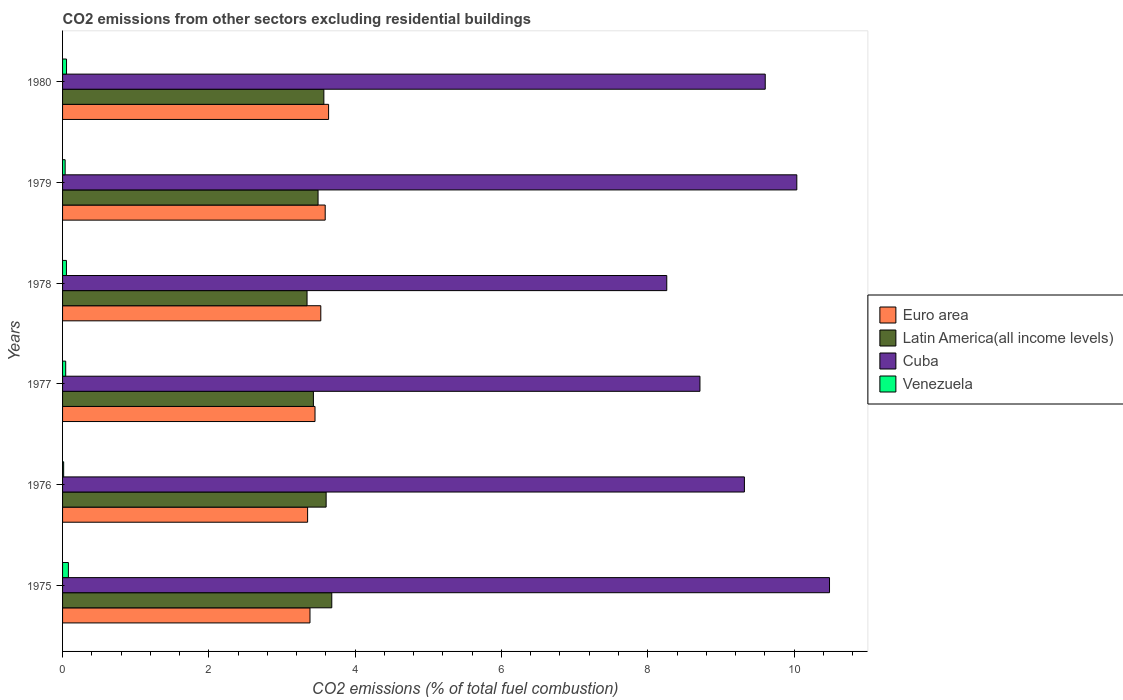How many different coloured bars are there?
Ensure brevity in your answer.  4. Are the number of bars per tick equal to the number of legend labels?
Your answer should be compact. Yes. How many bars are there on the 3rd tick from the top?
Keep it short and to the point. 4. How many bars are there on the 5th tick from the bottom?
Your answer should be very brief. 4. What is the label of the 6th group of bars from the top?
Ensure brevity in your answer.  1975. What is the total CO2 emitted in Euro area in 1977?
Ensure brevity in your answer.  3.45. Across all years, what is the maximum total CO2 emitted in Cuba?
Your answer should be very brief. 10.48. Across all years, what is the minimum total CO2 emitted in Latin America(all income levels)?
Your answer should be very brief. 3.34. In which year was the total CO2 emitted in Euro area maximum?
Give a very brief answer. 1980. In which year was the total CO2 emitted in Venezuela minimum?
Your answer should be compact. 1976. What is the total total CO2 emitted in Venezuela in the graph?
Make the answer very short. 0.28. What is the difference between the total CO2 emitted in Latin America(all income levels) in 1977 and that in 1978?
Ensure brevity in your answer.  0.09. What is the difference between the total CO2 emitted in Cuba in 1980 and the total CO2 emitted in Latin America(all income levels) in 1977?
Provide a succinct answer. 6.18. What is the average total CO2 emitted in Venezuela per year?
Your answer should be compact. 0.05. In the year 1975, what is the difference between the total CO2 emitted in Latin America(all income levels) and total CO2 emitted in Venezuela?
Give a very brief answer. 3.6. In how many years, is the total CO2 emitted in Cuba greater than 9.2 ?
Your response must be concise. 4. What is the ratio of the total CO2 emitted in Venezuela in 1975 to that in 1977?
Make the answer very short. 1.86. Is the total CO2 emitted in Euro area in 1976 less than that in 1978?
Offer a terse response. Yes. What is the difference between the highest and the second highest total CO2 emitted in Latin America(all income levels)?
Your answer should be compact. 0.08. What is the difference between the highest and the lowest total CO2 emitted in Latin America(all income levels)?
Provide a short and direct response. 0.34. In how many years, is the total CO2 emitted in Cuba greater than the average total CO2 emitted in Cuba taken over all years?
Your answer should be compact. 3. Is it the case that in every year, the sum of the total CO2 emitted in Euro area and total CO2 emitted in Venezuela is greater than the sum of total CO2 emitted in Latin America(all income levels) and total CO2 emitted in Cuba?
Your answer should be compact. Yes. What does the 3rd bar from the top in 1978 represents?
Ensure brevity in your answer.  Latin America(all income levels). What does the 3rd bar from the bottom in 1980 represents?
Offer a terse response. Cuba. Does the graph contain any zero values?
Your response must be concise. No. Does the graph contain grids?
Provide a succinct answer. No. Where does the legend appear in the graph?
Your response must be concise. Center right. How many legend labels are there?
Offer a terse response. 4. How are the legend labels stacked?
Your response must be concise. Vertical. What is the title of the graph?
Offer a very short reply. CO2 emissions from other sectors excluding residential buildings. Does "Guinea-Bissau" appear as one of the legend labels in the graph?
Your response must be concise. No. What is the label or title of the X-axis?
Keep it short and to the point. CO2 emissions (% of total fuel combustion). What is the label or title of the Y-axis?
Keep it short and to the point. Years. What is the CO2 emissions (% of total fuel combustion) of Euro area in 1975?
Offer a very short reply. 3.38. What is the CO2 emissions (% of total fuel combustion) in Latin America(all income levels) in 1975?
Offer a terse response. 3.68. What is the CO2 emissions (% of total fuel combustion) in Cuba in 1975?
Provide a succinct answer. 10.48. What is the CO2 emissions (% of total fuel combustion) in Venezuela in 1975?
Your answer should be compact. 0.08. What is the CO2 emissions (% of total fuel combustion) in Euro area in 1976?
Your response must be concise. 3.35. What is the CO2 emissions (% of total fuel combustion) in Latin America(all income levels) in 1976?
Your answer should be compact. 3.6. What is the CO2 emissions (% of total fuel combustion) of Cuba in 1976?
Ensure brevity in your answer.  9.32. What is the CO2 emissions (% of total fuel combustion) in Venezuela in 1976?
Your answer should be very brief. 0.01. What is the CO2 emissions (% of total fuel combustion) of Euro area in 1977?
Your response must be concise. 3.45. What is the CO2 emissions (% of total fuel combustion) in Latin America(all income levels) in 1977?
Offer a terse response. 3.43. What is the CO2 emissions (% of total fuel combustion) of Cuba in 1977?
Keep it short and to the point. 8.71. What is the CO2 emissions (% of total fuel combustion) of Venezuela in 1977?
Give a very brief answer. 0.04. What is the CO2 emissions (% of total fuel combustion) in Euro area in 1978?
Ensure brevity in your answer.  3.53. What is the CO2 emissions (% of total fuel combustion) of Latin America(all income levels) in 1978?
Offer a terse response. 3.34. What is the CO2 emissions (% of total fuel combustion) in Cuba in 1978?
Ensure brevity in your answer.  8.26. What is the CO2 emissions (% of total fuel combustion) in Venezuela in 1978?
Give a very brief answer. 0.05. What is the CO2 emissions (% of total fuel combustion) of Euro area in 1979?
Your answer should be very brief. 3.59. What is the CO2 emissions (% of total fuel combustion) of Latin America(all income levels) in 1979?
Your answer should be compact. 3.49. What is the CO2 emissions (% of total fuel combustion) in Cuba in 1979?
Make the answer very short. 10.04. What is the CO2 emissions (% of total fuel combustion) of Venezuela in 1979?
Ensure brevity in your answer.  0.04. What is the CO2 emissions (% of total fuel combustion) of Euro area in 1980?
Your response must be concise. 3.64. What is the CO2 emissions (% of total fuel combustion) in Latin America(all income levels) in 1980?
Provide a succinct answer. 3.57. What is the CO2 emissions (% of total fuel combustion) of Cuba in 1980?
Provide a succinct answer. 9.61. What is the CO2 emissions (% of total fuel combustion) in Venezuela in 1980?
Provide a short and direct response. 0.05. Across all years, what is the maximum CO2 emissions (% of total fuel combustion) of Euro area?
Your answer should be very brief. 3.64. Across all years, what is the maximum CO2 emissions (% of total fuel combustion) of Latin America(all income levels)?
Your answer should be compact. 3.68. Across all years, what is the maximum CO2 emissions (% of total fuel combustion) of Cuba?
Offer a very short reply. 10.48. Across all years, what is the maximum CO2 emissions (% of total fuel combustion) in Venezuela?
Offer a very short reply. 0.08. Across all years, what is the minimum CO2 emissions (% of total fuel combustion) of Euro area?
Your answer should be very brief. 3.35. Across all years, what is the minimum CO2 emissions (% of total fuel combustion) in Latin America(all income levels)?
Make the answer very short. 3.34. Across all years, what is the minimum CO2 emissions (% of total fuel combustion) in Cuba?
Offer a very short reply. 8.26. Across all years, what is the minimum CO2 emissions (% of total fuel combustion) of Venezuela?
Provide a succinct answer. 0.01. What is the total CO2 emissions (% of total fuel combustion) of Euro area in the graph?
Your answer should be compact. 20.94. What is the total CO2 emissions (% of total fuel combustion) of Latin America(all income levels) in the graph?
Your response must be concise. 21.12. What is the total CO2 emissions (% of total fuel combustion) of Cuba in the graph?
Your answer should be very brief. 56.42. What is the total CO2 emissions (% of total fuel combustion) of Venezuela in the graph?
Provide a short and direct response. 0.28. What is the difference between the CO2 emissions (% of total fuel combustion) in Euro area in 1975 and that in 1976?
Your answer should be compact. 0.03. What is the difference between the CO2 emissions (% of total fuel combustion) in Latin America(all income levels) in 1975 and that in 1976?
Your response must be concise. 0.08. What is the difference between the CO2 emissions (% of total fuel combustion) of Cuba in 1975 and that in 1976?
Provide a succinct answer. 1.16. What is the difference between the CO2 emissions (% of total fuel combustion) in Venezuela in 1975 and that in 1976?
Keep it short and to the point. 0.06. What is the difference between the CO2 emissions (% of total fuel combustion) of Euro area in 1975 and that in 1977?
Your response must be concise. -0.07. What is the difference between the CO2 emissions (% of total fuel combustion) in Latin America(all income levels) in 1975 and that in 1977?
Provide a succinct answer. 0.25. What is the difference between the CO2 emissions (% of total fuel combustion) of Cuba in 1975 and that in 1977?
Offer a terse response. 1.77. What is the difference between the CO2 emissions (% of total fuel combustion) in Venezuela in 1975 and that in 1977?
Provide a short and direct response. 0.04. What is the difference between the CO2 emissions (% of total fuel combustion) in Euro area in 1975 and that in 1978?
Your answer should be compact. -0.15. What is the difference between the CO2 emissions (% of total fuel combustion) in Latin America(all income levels) in 1975 and that in 1978?
Provide a succinct answer. 0.34. What is the difference between the CO2 emissions (% of total fuel combustion) of Cuba in 1975 and that in 1978?
Offer a terse response. 2.22. What is the difference between the CO2 emissions (% of total fuel combustion) in Venezuela in 1975 and that in 1978?
Your answer should be very brief. 0.03. What is the difference between the CO2 emissions (% of total fuel combustion) of Euro area in 1975 and that in 1979?
Ensure brevity in your answer.  -0.21. What is the difference between the CO2 emissions (% of total fuel combustion) in Latin America(all income levels) in 1975 and that in 1979?
Provide a succinct answer. 0.19. What is the difference between the CO2 emissions (% of total fuel combustion) in Cuba in 1975 and that in 1979?
Ensure brevity in your answer.  0.45. What is the difference between the CO2 emissions (% of total fuel combustion) of Venezuela in 1975 and that in 1979?
Provide a succinct answer. 0.04. What is the difference between the CO2 emissions (% of total fuel combustion) in Euro area in 1975 and that in 1980?
Offer a terse response. -0.25. What is the difference between the CO2 emissions (% of total fuel combustion) in Latin America(all income levels) in 1975 and that in 1980?
Ensure brevity in your answer.  0.11. What is the difference between the CO2 emissions (% of total fuel combustion) in Cuba in 1975 and that in 1980?
Offer a very short reply. 0.88. What is the difference between the CO2 emissions (% of total fuel combustion) in Venezuela in 1975 and that in 1980?
Provide a short and direct response. 0.03. What is the difference between the CO2 emissions (% of total fuel combustion) in Euro area in 1976 and that in 1977?
Your answer should be compact. -0.1. What is the difference between the CO2 emissions (% of total fuel combustion) of Latin America(all income levels) in 1976 and that in 1977?
Give a very brief answer. 0.17. What is the difference between the CO2 emissions (% of total fuel combustion) in Cuba in 1976 and that in 1977?
Your answer should be very brief. 0.61. What is the difference between the CO2 emissions (% of total fuel combustion) in Venezuela in 1976 and that in 1977?
Your answer should be compact. -0.03. What is the difference between the CO2 emissions (% of total fuel combustion) of Euro area in 1976 and that in 1978?
Provide a succinct answer. -0.18. What is the difference between the CO2 emissions (% of total fuel combustion) of Latin America(all income levels) in 1976 and that in 1978?
Offer a terse response. 0.26. What is the difference between the CO2 emissions (% of total fuel combustion) of Cuba in 1976 and that in 1978?
Offer a terse response. 1.06. What is the difference between the CO2 emissions (% of total fuel combustion) in Venezuela in 1976 and that in 1978?
Give a very brief answer. -0.04. What is the difference between the CO2 emissions (% of total fuel combustion) of Euro area in 1976 and that in 1979?
Give a very brief answer. -0.24. What is the difference between the CO2 emissions (% of total fuel combustion) of Latin America(all income levels) in 1976 and that in 1979?
Make the answer very short. 0.11. What is the difference between the CO2 emissions (% of total fuel combustion) of Cuba in 1976 and that in 1979?
Offer a terse response. -0.72. What is the difference between the CO2 emissions (% of total fuel combustion) in Venezuela in 1976 and that in 1979?
Provide a succinct answer. -0.02. What is the difference between the CO2 emissions (% of total fuel combustion) of Euro area in 1976 and that in 1980?
Offer a very short reply. -0.29. What is the difference between the CO2 emissions (% of total fuel combustion) of Latin America(all income levels) in 1976 and that in 1980?
Keep it short and to the point. 0.03. What is the difference between the CO2 emissions (% of total fuel combustion) in Cuba in 1976 and that in 1980?
Provide a succinct answer. -0.28. What is the difference between the CO2 emissions (% of total fuel combustion) of Venezuela in 1976 and that in 1980?
Your answer should be very brief. -0.04. What is the difference between the CO2 emissions (% of total fuel combustion) in Euro area in 1977 and that in 1978?
Ensure brevity in your answer.  -0.08. What is the difference between the CO2 emissions (% of total fuel combustion) in Latin America(all income levels) in 1977 and that in 1978?
Provide a succinct answer. 0.09. What is the difference between the CO2 emissions (% of total fuel combustion) in Cuba in 1977 and that in 1978?
Provide a short and direct response. 0.45. What is the difference between the CO2 emissions (% of total fuel combustion) in Venezuela in 1977 and that in 1978?
Your response must be concise. -0.01. What is the difference between the CO2 emissions (% of total fuel combustion) of Euro area in 1977 and that in 1979?
Make the answer very short. -0.14. What is the difference between the CO2 emissions (% of total fuel combustion) of Latin America(all income levels) in 1977 and that in 1979?
Keep it short and to the point. -0.06. What is the difference between the CO2 emissions (% of total fuel combustion) in Cuba in 1977 and that in 1979?
Your answer should be compact. -1.32. What is the difference between the CO2 emissions (% of total fuel combustion) in Venezuela in 1977 and that in 1979?
Make the answer very short. 0.01. What is the difference between the CO2 emissions (% of total fuel combustion) in Euro area in 1977 and that in 1980?
Ensure brevity in your answer.  -0.19. What is the difference between the CO2 emissions (% of total fuel combustion) in Latin America(all income levels) in 1977 and that in 1980?
Provide a succinct answer. -0.14. What is the difference between the CO2 emissions (% of total fuel combustion) in Cuba in 1977 and that in 1980?
Your response must be concise. -0.89. What is the difference between the CO2 emissions (% of total fuel combustion) in Venezuela in 1977 and that in 1980?
Your answer should be very brief. -0.01. What is the difference between the CO2 emissions (% of total fuel combustion) of Euro area in 1978 and that in 1979?
Offer a terse response. -0.06. What is the difference between the CO2 emissions (% of total fuel combustion) of Latin America(all income levels) in 1978 and that in 1979?
Your answer should be very brief. -0.15. What is the difference between the CO2 emissions (% of total fuel combustion) in Cuba in 1978 and that in 1979?
Offer a terse response. -1.78. What is the difference between the CO2 emissions (% of total fuel combustion) in Venezuela in 1978 and that in 1979?
Your response must be concise. 0.02. What is the difference between the CO2 emissions (% of total fuel combustion) of Euro area in 1978 and that in 1980?
Your answer should be very brief. -0.11. What is the difference between the CO2 emissions (% of total fuel combustion) in Latin America(all income levels) in 1978 and that in 1980?
Ensure brevity in your answer.  -0.23. What is the difference between the CO2 emissions (% of total fuel combustion) of Cuba in 1978 and that in 1980?
Ensure brevity in your answer.  -1.35. What is the difference between the CO2 emissions (% of total fuel combustion) of Venezuela in 1978 and that in 1980?
Provide a succinct answer. -0. What is the difference between the CO2 emissions (% of total fuel combustion) in Euro area in 1979 and that in 1980?
Your answer should be compact. -0.05. What is the difference between the CO2 emissions (% of total fuel combustion) of Latin America(all income levels) in 1979 and that in 1980?
Provide a short and direct response. -0.08. What is the difference between the CO2 emissions (% of total fuel combustion) of Cuba in 1979 and that in 1980?
Ensure brevity in your answer.  0.43. What is the difference between the CO2 emissions (% of total fuel combustion) in Venezuela in 1979 and that in 1980?
Your answer should be compact. -0.02. What is the difference between the CO2 emissions (% of total fuel combustion) of Euro area in 1975 and the CO2 emissions (% of total fuel combustion) of Latin America(all income levels) in 1976?
Your answer should be compact. -0.22. What is the difference between the CO2 emissions (% of total fuel combustion) of Euro area in 1975 and the CO2 emissions (% of total fuel combustion) of Cuba in 1976?
Make the answer very short. -5.94. What is the difference between the CO2 emissions (% of total fuel combustion) of Euro area in 1975 and the CO2 emissions (% of total fuel combustion) of Venezuela in 1976?
Give a very brief answer. 3.37. What is the difference between the CO2 emissions (% of total fuel combustion) of Latin America(all income levels) in 1975 and the CO2 emissions (% of total fuel combustion) of Cuba in 1976?
Offer a terse response. -5.64. What is the difference between the CO2 emissions (% of total fuel combustion) in Latin America(all income levels) in 1975 and the CO2 emissions (% of total fuel combustion) in Venezuela in 1976?
Offer a very short reply. 3.67. What is the difference between the CO2 emissions (% of total fuel combustion) in Cuba in 1975 and the CO2 emissions (% of total fuel combustion) in Venezuela in 1976?
Give a very brief answer. 10.47. What is the difference between the CO2 emissions (% of total fuel combustion) of Euro area in 1975 and the CO2 emissions (% of total fuel combustion) of Latin America(all income levels) in 1977?
Your answer should be very brief. -0.05. What is the difference between the CO2 emissions (% of total fuel combustion) in Euro area in 1975 and the CO2 emissions (% of total fuel combustion) in Cuba in 1977?
Ensure brevity in your answer.  -5.33. What is the difference between the CO2 emissions (% of total fuel combustion) of Euro area in 1975 and the CO2 emissions (% of total fuel combustion) of Venezuela in 1977?
Provide a short and direct response. 3.34. What is the difference between the CO2 emissions (% of total fuel combustion) of Latin America(all income levels) in 1975 and the CO2 emissions (% of total fuel combustion) of Cuba in 1977?
Ensure brevity in your answer.  -5.03. What is the difference between the CO2 emissions (% of total fuel combustion) of Latin America(all income levels) in 1975 and the CO2 emissions (% of total fuel combustion) of Venezuela in 1977?
Your response must be concise. 3.64. What is the difference between the CO2 emissions (% of total fuel combustion) in Cuba in 1975 and the CO2 emissions (% of total fuel combustion) in Venezuela in 1977?
Make the answer very short. 10.44. What is the difference between the CO2 emissions (% of total fuel combustion) of Euro area in 1975 and the CO2 emissions (% of total fuel combustion) of Latin America(all income levels) in 1978?
Give a very brief answer. 0.04. What is the difference between the CO2 emissions (% of total fuel combustion) of Euro area in 1975 and the CO2 emissions (% of total fuel combustion) of Cuba in 1978?
Your answer should be very brief. -4.88. What is the difference between the CO2 emissions (% of total fuel combustion) in Euro area in 1975 and the CO2 emissions (% of total fuel combustion) in Venezuela in 1978?
Offer a very short reply. 3.33. What is the difference between the CO2 emissions (% of total fuel combustion) in Latin America(all income levels) in 1975 and the CO2 emissions (% of total fuel combustion) in Cuba in 1978?
Offer a very short reply. -4.58. What is the difference between the CO2 emissions (% of total fuel combustion) in Latin America(all income levels) in 1975 and the CO2 emissions (% of total fuel combustion) in Venezuela in 1978?
Provide a short and direct response. 3.63. What is the difference between the CO2 emissions (% of total fuel combustion) in Cuba in 1975 and the CO2 emissions (% of total fuel combustion) in Venezuela in 1978?
Keep it short and to the point. 10.43. What is the difference between the CO2 emissions (% of total fuel combustion) of Euro area in 1975 and the CO2 emissions (% of total fuel combustion) of Latin America(all income levels) in 1979?
Offer a very short reply. -0.11. What is the difference between the CO2 emissions (% of total fuel combustion) of Euro area in 1975 and the CO2 emissions (% of total fuel combustion) of Cuba in 1979?
Keep it short and to the point. -6.66. What is the difference between the CO2 emissions (% of total fuel combustion) of Euro area in 1975 and the CO2 emissions (% of total fuel combustion) of Venezuela in 1979?
Offer a terse response. 3.35. What is the difference between the CO2 emissions (% of total fuel combustion) in Latin America(all income levels) in 1975 and the CO2 emissions (% of total fuel combustion) in Cuba in 1979?
Ensure brevity in your answer.  -6.36. What is the difference between the CO2 emissions (% of total fuel combustion) of Latin America(all income levels) in 1975 and the CO2 emissions (% of total fuel combustion) of Venezuela in 1979?
Provide a succinct answer. 3.65. What is the difference between the CO2 emissions (% of total fuel combustion) in Cuba in 1975 and the CO2 emissions (% of total fuel combustion) in Venezuela in 1979?
Make the answer very short. 10.45. What is the difference between the CO2 emissions (% of total fuel combustion) of Euro area in 1975 and the CO2 emissions (% of total fuel combustion) of Latin America(all income levels) in 1980?
Keep it short and to the point. -0.19. What is the difference between the CO2 emissions (% of total fuel combustion) of Euro area in 1975 and the CO2 emissions (% of total fuel combustion) of Cuba in 1980?
Your answer should be compact. -6.22. What is the difference between the CO2 emissions (% of total fuel combustion) in Euro area in 1975 and the CO2 emissions (% of total fuel combustion) in Venezuela in 1980?
Make the answer very short. 3.33. What is the difference between the CO2 emissions (% of total fuel combustion) in Latin America(all income levels) in 1975 and the CO2 emissions (% of total fuel combustion) in Cuba in 1980?
Give a very brief answer. -5.93. What is the difference between the CO2 emissions (% of total fuel combustion) of Latin America(all income levels) in 1975 and the CO2 emissions (% of total fuel combustion) of Venezuela in 1980?
Provide a short and direct response. 3.63. What is the difference between the CO2 emissions (% of total fuel combustion) in Cuba in 1975 and the CO2 emissions (% of total fuel combustion) in Venezuela in 1980?
Ensure brevity in your answer.  10.43. What is the difference between the CO2 emissions (% of total fuel combustion) in Euro area in 1976 and the CO2 emissions (% of total fuel combustion) in Latin America(all income levels) in 1977?
Your answer should be very brief. -0.08. What is the difference between the CO2 emissions (% of total fuel combustion) of Euro area in 1976 and the CO2 emissions (% of total fuel combustion) of Cuba in 1977?
Ensure brevity in your answer.  -5.36. What is the difference between the CO2 emissions (% of total fuel combustion) in Euro area in 1976 and the CO2 emissions (% of total fuel combustion) in Venezuela in 1977?
Provide a short and direct response. 3.31. What is the difference between the CO2 emissions (% of total fuel combustion) of Latin America(all income levels) in 1976 and the CO2 emissions (% of total fuel combustion) of Cuba in 1977?
Keep it short and to the point. -5.11. What is the difference between the CO2 emissions (% of total fuel combustion) in Latin America(all income levels) in 1976 and the CO2 emissions (% of total fuel combustion) in Venezuela in 1977?
Your answer should be compact. 3.56. What is the difference between the CO2 emissions (% of total fuel combustion) in Cuba in 1976 and the CO2 emissions (% of total fuel combustion) in Venezuela in 1977?
Keep it short and to the point. 9.28. What is the difference between the CO2 emissions (% of total fuel combustion) in Euro area in 1976 and the CO2 emissions (% of total fuel combustion) in Latin America(all income levels) in 1978?
Your answer should be compact. 0.01. What is the difference between the CO2 emissions (% of total fuel combustion) of Euro area in 1976 and the CO2 emissions (% of total fuel combustion) of Cuba in 1978?
Offer a terse response. -4.91. What is the difference between the CO2 emissions (% of total fuel combustion) of Euro area in 1976 and the CO2 emissions (% of total fuel combustion) of Venezuela in 1978?
Make the answer very short. 3.3. What is the difference between the CO2 emissions (% of total fuel combustion) of Latin America(all income levels) in 1976 and the CO2 emissions (% of total fuel combustion) of Cuba in 1978?
Provide a short and direct response. -4.66. What is the difference between the CO2 emissions (% of total fuel combustion) in Latin America(all income levels) in 1976 and the CO2 emissions (% of total fuel combustion) in Venezuela in 1978?
Keep it short and to the point. 3.55. What is the difference between the CO2 emissions (% of total fuel combustion) of Cuba in 1976 and the CO2 emissions (% of total fuel combustion) of Venezuela in 1978?
Keep it short and to the point. 9.27. What is the difference between the CO2 emissions (% of total fuel combustion) in Euro area in 1976 and the CO2 emissions (% of total fuel combustion) in Latin America(all income levels) in 1979?
Provide a succinct answer. -0.14. What is the difference between the CO2 emissions (% of total fuel combustion) of Euro area in 1976 and the CO2 emissions (% of total fuel combustion) of Cuba in 1979?
Provide a short and direct response. -6.69. What is the difference between the CO2 emissions (% of total fuel combustion) of Euro area in 1976 and the CO2 emissions (% of total fuel combustion) of Venezuela in 1979?
Offer a terse response. 3.31. What is the difference between the CO2 emissions (% of total fuel combustion) of Latin America(all income levels) in 1976 and the CO2 emissions (% of total fuel combustion) of Cuba in 1979?
Ensure brevity in your answer.  -6.43. What is the difference between the CO2 emissions (% of total fuel combustion) in Latin America(all income levels) in 1976 and the CO2 emissions (% of total fuel combustion) in Venezuela in 1979?
Offer a very short reply. 3.57. What is the difference between the CO2 emissions (% of total fuel combustion) of Cuba in 1976 and the CO2 emissions (% of total fuel combustion) of Venezuela in 1979?
Give a very brief answer. 9.29. What is the difference between the CO2 emissions (% of total fuel combustion) of Euro area in 1976 and the CO2 emissions (% of total fuel combustion) of Latin America(all income levels) in 1980?
Provide a short and direct response. -0.22. What is the difference between the CO2 emissions (% of total fuel combustion) of Euro area in 1976 and the CO2 emissions (% of total fuel combustion) of Cuba in 1980?
Provide a short and direct response. -6.26. What is the difference between the CO2 emissions (% of total fuel combustion) in Euro area in 1976 and the CO2 emissions (% of total fuel combustion) in Venezuela in 1980?
Provide a succinct answer. 3.3. What is the difference between the CO2 emissions (% of total fuel combustion) of Latin America(all income levels) in 1976 and the CO2 emissions (% of total fuel combustion) of Cuba in 1980?
Keep it short and to the point. -6. What is the difference between the CO2 emissions (% of total fuel combustion) of Latin America(all income levels) in 1976 and the CO2 emissions (% of total fuel combustion) of Venezuela in 1980?
Offer a terse response. 3.55. What is the difference between the CO2 emissions (% of total fuel combustion) of Cuba in 1976 and the CO2 emissions (% of total fuel combustion) of Venezuela in 1980?
Your answer should be very brief. 9.27. What is the difference between the CO2 emissions (% of total fuel combustion) in Euro area in 1977 and the CO2 emissions (% of total fuel combustion) in Latin America(all income levels) in 1978?
Provide a succinct answer. 0.11. What is the difference between the CO2 emissions (% of total fuel combustion) of Euro area in 1977 and the CO2 emissions (% of total fuel combustion) of Cuba in 1978?
Offer a terse response. -4.81. What is the difference between the CO2 emissions (% of total fuel combustion) of Euro area in 1977 and the CO2 emissions (% of total fuel combustion) of Venezuela in 1978?
Your answer should be compact. 3.4. What is the difference between the CO2 emissions (% of total fuel combustion) in Latin America(all income levels) in 1977 and the CO2 emissions (% of total fuel combustion) in Cuba in 1978?
Make the answer very short. -4.83. What is the difference between the CO2 emissions (% of total fuel combustion) in Latin America(all income levels) in 1977 and the CO2 emissions (% of total fuel combustion) in Venezuela in 1978?
Offer a terse response. 3.38. What is the difference between the CO2 emissions (% of total fuel combustion) in Cuba in 1977 and the CO2 emissions (% of total fuel combustion) in Venezuela in 1978?
Keep it short and to the point. 8.66. What is the difference between the CO2 emissions (% of total fuel combustion) of Euro area in 1977 and the CO2 emissions (% of total fuel combustion) of Latin America(all income levels) in 1979?
Make the answer very short. -0.04. What is the difference between the CO2 emissions (% of total fuel combustion) in Euro area in 1977 and the CO2 emissions (% of total fuel combustion) in Cuba in 1979?
Your response must be concise. -6.59. What is the difference between the CO2 emissions (% of total fuel combustion) of Euro area in 1977 and the CO2 emissions (% of total fuel combustion) of Venezuela in 1979?
Provide a succinct answer. 3.42. What is the difference between the CO2 emissions (% of total fuel combustion) in Latin America(all income levels) in 1977 and the CO2 emissions (% of total fuel combustion) in Cuba in 1979?
Your response must be concise. -6.61. What is the difference between the CO2 emissions (% of total fuel combustion) in Latin America(all income levels) in 1977 and the CO2 emissions (% of total fuel combustion) in Venezuela in 1979?
Your answer should be compact. 3.39. What is the difference between the CO2 emissions (% of total fuel combustion) in Cuba in 1977 and the CO2 emissions (% of total fuel combustion) in Venezuela in 1979?
Your answer should be very brief. 8.68. What is the difference between the CO2 emissions (% of total fuel combustion) of Euro area in 1977 and the CO2 emissions (% of total fuel combustion) of Latin America(all income levels) in 1980?
Ensure brevity in your answer.  -0.12. What is the difference between the CO2 emissions (% of total fuel combustion) in Euro area in 1977 and the CO2 emissions (% of total fuel combustion) in Cuba in 1980?
Your answer should be very brief. -6.15. What is the difference between the CO2 emissions (% of total fuel combustion) of Euro area in 1977 and the CO2 emissions (% of total fuel combustion) of Venezuela in 1980?
Provide a succinct answer. 3.4. What is the difference between the CO2 emissions (% of total fuel combustion) in Latin America(all income levels) in 1977 and the CO2 emissions (% of total fuel combustion) in Cuba in 1980?
Provide a short and direct response. -6.18. What is the difference between the CO2 emissions (% of total fuel combustion) of Latin America(all income levels) in 1977 and the CO2 emissions (% of total fuel combustion) of Venezuela in 1980?
Make the answer very short. 3.37. What is the difference between the CO2 emissions (% of total fuel combustion) in Cuba in 1977 and the CO2 emissions (% of total fuel combustion) in Venezuela in 1980?
Offer a terse response. 8.66. What is the difference between the CO2 emissions (% of total fuel combustion) in Euro area in 1978 and the CO2 emissions (% of total fuel combustion) in Latin America(all income levels) in 1979?
Keep it short and to the point. 0.04. What is the difference between the CO2 emissions (% of total fuel combustion) of Euro area in 1978 and the CO2 emissions (% of total fuel combustion) of Cuba in 1979?
Offer a very short reply. -6.51. What is the difference between the CO2 emissions (% of total fuel combustion) in Euro area in 1978 and the CO2 emissions (% of total fuel combustion) in Venezuela in 1979?
Ensure brevity in your answer.  3.5. What is the difference between the CO2 emissions (% of total fuel combustion) of Latin America(all income levels) in 1978 and the CO2 emissions (% of total fuel combustion) of Cuba in 1979?
Ensure brevity in your answer.  -6.7. What is the difference between the CO2 emissions (% of total fuel combustion) of Latin America(all income levels) in 1978 and the CO2 emissions (% of total fuel combustion) of Venezuela in 1979?
Your answer should be compact. 3.31. What is the difference between the CO2 emissions (% of total fuel combustion) of Cuba in 1978 and the CO2 emissions (% of total fuel combustion) of Venezuela in 1979?
Make the answer very short. 8.22. What is the difference between the CO2 emissions (% of total fuel combustion) of Euro area in 1978 and the CO2 emissions (% of total fuel combustion) of Latin America(all income levels) in 1980?
Your response must be concise. -0.04. What is the difference between the CO2 emissions (% of total fuel combustion) of Euro area in 1978 and the CO2 emissions (% of total fuel combustion) of Cuba in 1980?
Offer a terse response. -6.08. What is the difference between the CO2 emissions (% of total fuel combustion) of Euro area in 1978 and the CO2 emissions (% of total fuel combustion) of Venezuela in 1980?
Keep it short and to the point. 3.48. What is the difference between the CO2 emissions (% of total fuel combustion) in Latin America(all income levels) in 1978 and the CO2 emissions (% of total fuel combustion) in Cuba in 1980?
Make the answer very short. -6.26. What is the difference between the CO2 emissions (% of total fuel combustion) in Latin America(all income levels) in 1978 and the CO2 emissions (% of total fuel combustion) in Venezuela in 1980?
Provide a succinct answer. 3.29. What is the difference between the CO2 emissions (% of total fuel combustion) in Cuba in 1978 and the CO2 emissions (% of total fuel combustion) in Venezuela in 1980?
Provide a short and direct response. 8.21. What is the difference between the CO2 emissions (% of total fuel combustion) in Euro area in 1979 and the CO2 emissions (% of total fuel combustion) in Latin America(all income levels) in 1980?
Make the answer very short. 0.02. What is the difference between the CO2 emissions (% of total fuel combustion) in Euro area in 1979 and the CO2 emissions (% of total fuel combustion) in Cuba in 1980?
Provide a succinct answer. -6.02. What is the difference between the CO2 emissions (% of total fuel combustion) of Euro area in 1979 and the CO2 emissions (% of total fuel combustion) of Venezuela in 1980?
Keep it short and to the point. 3.54. What is the difference between the CO2 emissions (% of total fuel combustion) in Latin America(all income levels) in 1979 and the CO2 emissions (% of total fuel combustion) in Cuba in 1980?
Provide a short and direct response. -6.11. What is the difference between the CO2 emissions (% of total fuel combustion) of Latin America(all income levels) in 1979 and the CO2 emissions (% of total fuel combustion) of Venezuela in 1980?
Keep it short and to the point. 3.44. What is the difference between the CO2 emissions (% of total fuel combustion) in Cuba in 1979 and the CO2 emissions (% of total fuel combustion) in Venezuela in 1980?
Offer a terse response. 9.98. What is the average CO2 emissions (% of total fuel combustion) of Euro area per year?
Provide a succinct answer. 3.49. What is the average CO2 emissions (% of total fuel combustion) of Latin America(all income levels) per year?
Your answer should be compact. 3.52. What is the average CO2 emissions (% of total fuel combustion) of Cuba per year?
Give a very brief answer. 9.4. What is the average CO2 emissions (% of total fuel combustion) in Venezuela per year?
Your answer should be very brief. 0.05. In the year 1975, what is the difference between the CO2 emissions (% of total fuel combustion) of Euro area and CO2 emissions (% of total fuel combustion) of Latin America(all income levels)?
Provide a short and direct response. -0.3. In the year 1975, what is the difference between the CO2 emissions (% of total fuel combustion) of Euro area and CO2 emissions (% of total fuel combustion) of Cuba?
Your answer should be compact. -7.1. In the year 1975, what is the difference between the CO2 emissions (% of total fuel combustion) of Euro area and CO2 emissions (% of total fuel combustion) of Venezuela?
Your answer should be compact. 3.3. In the year 1975, what is the difference between the CO2 emissions (% of total fuel combustion) in Latin America(all income levels) and CO2 emissions (% of total fuel combustion) in Cuba?
Offer a terse response. -6.8. In the year 1975, what is the difference between the CO2 emissions (% of total fuel combustion) of Latin America(all income levels) and CO2 emissions (% of total fuel combustion) of Venezuela?
Offer a very short reply. 3.6. In the year 1975, what is the difference between the CO2 emissions (% of total fuel combustion) of Cuba and CO2 emissions (% of total fuel combustion) of Venezuela?
Provide a short and direct response. 10.4. In the year 1976, what is the difference between the CO2 emissions (% of total fuel combustion) of Euro area and CO2 emissions (% of total fuel combustion) of Latin America(all income levels)?
Provide a short and direct response. -0.25. In the year 1976, what is the difference between the CO2 emissions (% of total fuel combustion) of Euro area and CO2 emissions (% of total fuel combustion) of Cuba?
Your answer should be compact. -5.97. In the year 1976, what is the difference between the CO2 emissions (% of total fuel combustion) in Euro area and CO2 emissions (% of total fuel combustion) in Venezuela?
Keep it short and to the point. 3.33. In the year 1976, what is the difference between the CO2 emissions (% of total fuel combustion) in Latin America(all income levels) and CO2 emissions (% of total fuel combustion) in Cuba?
Offer a terse response. -5.72. In the year 1976, what is the difference between the CO2 emissions (% of total fuel combustion) in Latin America(all income levels) and CO2 emissions (% of total fuel combustion) in Venezuela?
Keep it short and to the point. 3.59. In the year 1976, what is the difference between the CO2 emissions (% of total fuel combustion) of Cuba and CO2 emissions (% of total fuel combustion) of Venezuela?
Offer a very short reply. 9.31. In the year 1977, what is the difference between the CO2 emissions (% of total fuel combustion) of Euro area and CO2 emissions (% of total fuel combustion) of Latin America(all income levels)?
Provide a succinct answer. 0.02. In the year 1977, what is the difference between the CO2 emissions (% of total fuel combustion) in Euro area and CO2 emissions (% of total fuel combustion) in Cuba?
Offer a terse response. -5.26. In the year 1977, what is the difference between the CO2 emissions (% of total fuel combustion) in Euro area and CO2 emissions (% of total fuel combustion) in Venezuela?
Give a very brief answer. 3.41. In the year 1977, what is the difference between the CO2 emissions (% of total fuel combustion) in Latin America(all income levels) and CO2 emissions (% of total fuel combustion) in Cuba?
Offer a very short reply. -5.28. In the year 1977, what is the difference between the CO2 emissions (% of total fuel combustion) of Latin America(all income levels) and CO2 emissions (% of total fuel combustion) of Venezuela?
Your response must be concise. 3.39. In the year 1977, what is the difference between the CO2 emissions (% of total fuel combustion) of Cuba and CO2 emissions (% of total fuel combustion) of Venezuela?
Offer a terse response. 8.67. In the year 1978, what is the difference between the CO2 emissions (% of total fuel combustion) in Euro area and CO2 emissions (% of total fuel combustion) in Latin America(all income levels)?
Offer a very short reply. 0.19. In the year 1978, what is the difference between the CO2 emissions (% of total fuel combustion) of Euro area and CO2 emissions (% of total fuel combustion) of Cuba?
Keep it short and to the point. -4.73. In the year 1978, what is the difference between the CO2 emissions (% of total fuel combustion) in Euro area and CO2 emissions (% of total fuel combustion) in Venezuela?
Offer a very short reply. 3.48. In the year 1978, what is the difference between the CO2 emissions (% of total fuel combustion) of Latin America(all income levels) and CO2 emissions (% of total fuel combustion) of Cuba?
Your answer should be very brief. -4.92. In the year 1978, what is the difference between the CO2 emissions (% of total fuel combustion) in Latin America(all income levels) and CO2 emissions (% of total fuel combustion) in Venezuela?
Your response must be concise. 3.29. In the year 1978, what is the difference between the CO2 emissions (% of total fuel combustion) of Cuba and CO2 emissions (% of total fuel combustion) of Venezuela?
Your answer should be very brief. 8.21. In the year 1979, what is the difference between the CO2 emissions (% of total fuel combustion) of Euro area and CO2 emissions (% of total fuel combustion) of Latin America(all income levels)?
Your response must be concise. 0.1. In the year 1979, what is the difference between the CO2 emissions (% of total fuel combustion) of Euro area and CO2 emissions (% of total fuel combustion) of Cuba?
Your answer should be very brief. -6.45. In the year 1979, what is the difference between the CO2 emissions (% of total fuel combustion) of Euro area and CO2 emissions (% of total fuel combustion) of Venezuela?
Ensure brevity in your answer.  3.56. In the year 1979, what is the difference between the CO2 emissions (% of total fuel combustion) of Latin America(all income levels) and CO2 emissions (% of total fuel combustion) of Cuba?
Your answer should be compact. -6.54. In the year 1979, what is the difference between the CO2 emissions (% of total fuel combustion) in Latin America(all income levels) and CO2 emissions (% of total fuel combustion) in Venezuela?
Offer a terse response. 3.46. In the year 1979, what is the difference between the CO2 emissions (% of total fuel combustion) in Cuba and CO2 emissions (% of total fuel combustion) in Venezuela?
Provide a succinct answer. 10. In the year 1980, what is the difference between the CO2 emissions (% of total fuel combustion) in Euro area and CO2 emissions (% of total fuel combustion) in Latin America(all income levels)?
Make the answer very short. 0.06. In the year 1980, what is the difference between the CO2 emissions (% of total fuel combustion) in Euro area and CO2 emissions (% of total fuel combustion) in Cuba?
Provide a short and direct response. -5.97. In the year 1980, what is the difference between the CO2 emissions (% of total fuel combustion) in Euro area and CO2 emissions (% of total fuel combustion) in Venezuela?
Give a very brief answer. 3.58. In the year 1980, what is the difference between the CO2 emissions (% of total fuel combustion) of Latin America(all income levels) and CO2 emissions (% of total fuel combustion) of Cuba?
Offer a very short reply. -6.03. In the year 1980, what is the difference between the CO2 emissions (% of total fuel combustion) in Latin America(all income levels) and CO2 emissions (% of total fuel combustion) in Venezuela?
Keep it short and to the point. 3.52. In the year 1980, what is the difference between the CO2 emissions (% of total fuel combustion) of Cuba and CO2 emissions (% of total fuel combustion) of Venezuela?
Keep it short and to the point. 9.55. What is the ratio of the CO2 emissions (% of total fuel combustion) in Euro area in 1975 to that in 1976?
Make the answer very short. 1.01. What is the ratio of the CO2 emissions (% of total fuel combustion) in Latin America(all income levels) in 1975 to that in 1976?
Keep it short and to the point. 1.02. What is the ratio of the CO2 emissions (% of total fuel combustion) of Cuba in 1975 to that in 1976?
Your answer should be compact. 1.12. What is the ratio of the CO2 emissions (% of total fuel combustion) in Venezuela in 1975 to that in 1976?
Offer a terse response. 5.37. What is the ratio of the CO2 emissions (% of total fuel combustion) of Euro area in 1975 to that in 1977?
Offer a very short reply. 0.98. What is the ratio of the CO2 emissions (% of total fuel combustion) of Latin America(all income levels) in 1975 to that in 1977?
Make the answer very short. 1.07. What is the ratio of the CO2 emissions (% of total fuel combustion) of Cuba in 1975 to that in 1977?
Make the answer very short. 1.2. What is the ratio of the CO2 emissions (% of total fuel combustion) in Venezuela in 1975 to that in 1977?
Make the answer very short. 1.86. What is the ratio of the CO2 emissions (% of total fuel combustion) in Euro area in 1975 to that in 1978?
Your answer should be very brief. 0.96. What is the ratio of the CO2 emissions (% of total fuel combustion) of Latin America(all income levels) in 1975 to that in 1978?
Your answer should be compact. 1.1. What is the ratio of the CO2 emissions (% of total fuel combustion) of Cuba in 1975 to that in 1978?
Provide a short and direct response. 1.27. What is the ratio of the CO2 emissions (% of total fuel combustion) of Venezuela in 1975 to that in 1978?
Provide a succinct answer. 1.5. What is the ratio of the CO2 emissions (% of total fuel combustion) in Euro area in 1975 to that in 1979?
Provide a succinct answer. 0.94. What is the ratio of the CO2 emissions (% of total fuel combustion) of Latin America(all income levels) in 1975 to that in 1979?
Keep it short and to the point. 1.05. What is the ratio of the CO2 emissions (% of total fuel combustion) in Cuba in 1975 to that in 1979?
Offer a very short reply. 1.04. What is the ratio of the CO2 emissions (% of total fuel combustion) in Venezuela in 1975 to that in 1979?
Offer a very short reply. 2.26. What is the ratio of the CO2 emissions (% of total fuel combustion) of Euro area in 1975 to that in 1980?
Your answer should be very brief. 0.93. What is the ratio of the CO2 emissions (% of total fuel combustion) of Latin America(all income levels) in 1975 to that in 1980?
Provide a short and direct response. 1.03. What is the ratio of the CO2 emissions (% of total fuel combustion) of Cuba in 1975 to that in 1980?
Provide a succinct answer. 1.09. What is the ratio of the CO2 emissions (% of total fuel combustion) of Venezuela in 1975 to that in 1980?
Ensure brevity in your answer.  1.47. What is the ratio of the CO2 emissions (% of total fuel combustion) of Euro area in 1976 to that in 1977?
Your answer should be very brief. 0.97. What is the ratio of the CO2 emissions (% of total fuel combustion) of Latin America(all income levels) in 1976 to that in 1977?
Offer a very short reply. 1.05. What is the ratio of the CO2 emissions (% of total fuel combustion) of Cuba in 1976 to that in 1977?
Your answer should be very brief. 1.07. What is the ratio of the CO2 emissions (% of total fuel combustion) of Venezuela in 1976 to that in 1977?
Your response must be concise. 0.35. What is the ratio of the CO2 emissions (% of total fuel combustion) in Euro area in 1976 to that in 1978?
Provide a succinct answer. 0.95. What is the ratio of the CO2 emissions (% of total fuel combustion) in Latin America(all income levels) in 1976 to that in 1978?
Make the answer very short. 1.08. What is the ratio of the CO2 emissions (% of total fuel combustion) of Cuba in 1976 to that in 1978?
Provide a succinct answer. 1.13. What is the ratio of the CO2 emissions (% of total fuel combustion) in Venezuela in 1976 to that in 1978?
Make the answer very short. 0.28. What is the ratio of the CO2 emissions (% of total fuel combustion) of Euro area in 1976 to that in 1979?
Offer a terse response. 0.93. What is the ratio of the CO2 emissions (% of total fuel combustion) in Latin America(all income levels) in 1976 to that in 1979?
Give a very brief answer. 1.03. What is the ratio of the CO2 emissions (% of total fuel combustion) in Cuba in 1976 to that in 1979?
Ensure brevity in your answer.  0.93. What is the ratio of the CO2 emissions (% of total fuel combustion) of Venezuela in 1976 to that in 1979?
Give a very brief answer. 0.42. What is the ratio of the CO2 emissions (% of total fuel combustion) in Euro area in 1976 to that in 1980?
Give a very brief answer. 0.92. What is the ratio of the CO2 emissions (% of total fuel combustion) of Latin America(all income levels) in 1976 to that in 1980?
Provide a short and direct response. 1.01. What is the ratio of the CO2 emissions (% of total fuel combustion) in Cuba in 1976 to that in 1980?
Your answer should be compact. 0.97. What is the ratio of the CO2 emissions (% of total fuel combustion) of Venezuela in 1976 to that in 1980?
Your answer should be compact. 0.27. What is the ratio of the CO2 emissions (% of total fuel combustion) in Euro area in 1977 to that in 1978?
Provide a succinct answer. 0.98. What is the ratio of the CO2 emissions (% of total fuel combustion) of Cuba in 1977 to that in 1978?
Offer a very short reply. 1.05. What is the ratio of the CO2 emissions (% of total fuel combustion) in Venezuela in 1977 to that in 1978?
Your answer should be compact. 0.81. What is the ratio of the CO2 emissions (% of total fuel combustion) in Euro area in 1977 to that in 1979?
Your answer should be compact. 0.96. What is the ratio of the CO2 emissions (% of total fuel combustion) in Latin America(all income levels) in 1977 to that in 1979?
Offer a terse response. 0.98. What is the ratio of the CO2 emissions (% of total fuel combustion) in Cuba in 1977 to that in 1979?
Offer a very short reply. 0.87. What is the ratio of the CO2 emissions (% of total fuel combustion) of Venezuela in 1977 to that in 1979?
Provide a succinct answer. 1.22. What is the ratio of the CO2 emissions (% of total fuel combustion) of Euro area in 1977 to that in 1980?
Provide a short and direct response. 0.95. What is the ratio of the CO2 emissions (% of total fuel combustion) in Cuba in 1977 to that in 1980?
Ensure brevity in your answer.  0.91. What is the ratio of the CO2 emissions (% of total fuel combustion) in Venezuela in 1977 to that in 1980?
Provide a succinct answer. 0.79. What is the ratio of the CO2 emissions (% of total fuel combustion) in Euro area in 1978 to that in 1979?
Your answer should be compact. 0.98. What is the ratio of the CO2 emissions (% of total fuel combustion) in Latin America(all income levels) in 1978 to that in 1979?
Your response must be concise. 0.96. What is the ratio of the CO2 emissions (% of total fuel combustion) in Cuba in 1978 to that in 1979?
Ensure brevity in your answer.  0.82. What is the ratio of the CO2 emissions (% of total fuel combustion) in Venezuela in 1978 to that in 1979?
Your answer should be compact. 1.5. What is the ratio of the CO2 emissions (% of total fuel combustion) in Euro area in 1978 to that in 1980?
Offer a very short reply. 0.97. What is the ratio of the CO2 emissions (% of total fuel combustion) in Latin America(all income levels) in 1978 to that in 1980?
Provide a short and direct response. 0.94. What is the ratio of the CO2 emissions (% of total fuel combustion) in Cuba in 1978 to that in 1980?
Offer a terse response. 0.86. What is the ratio of the CO2 emissions (% of total fuel combustion) in Venezuela in 1978 to that in 1980?
Offer a very short reply. 0.98. What is the ratio of the CO2 emissions (% of total fuel combustion) in Euro area in 1979 to that in 1980?
Offer a terse response. 0.99. What is the ratio of the CO2 emissions (% of total fuel combustion) in Latin America(all income levels) in 1979 to that in 1980?
Offer a very short reply. 0.98. What is the ratio of the CO2 emissions (% of total fuel combustion) in Cuba in 1979 to that in 1980?
Give a very brief answer. 1.04. What is the ratio of the CO2 emissions (% of total fuel combustion) of Venezuela in 1979 to that in 1980?
Keep it short and to the point. 0.65. What is the difference between the highest and the second highest CO2 emissions (% of total fuel combustion) of Euro area?
Ensure brevity in your answer.  0.05. What is the difference between the highest and the second highest CO2 emissions (% of total fuel combustion) of Latin America(all income levels)?
Keep it short and to the point. 0.08. What is the difference between the highest and the second highest CO2 emissions (% of total fuel combustion) of Cuba?
Keep it short and to the point. 0.45. What is the difference between the highest and the second highest CO2 emissions (% of total fuel combustion) of Venezuela?
Make the answer very short. 0.03. What is the difference between the highest and the lowest CO2 emissions (% of total fuel combustion) of Euro area?
Make the answer very short. 0.29. What is the difference between the highest and the lowest CO2 emissions (% of total fuel combustion) in Latin America(all income levels)?
Your answer should be compact. 0.34. What is the difference between the highest and the lowest CO2 emissions (% of total fuel combustion) in Cuba?
Your response must be concise. 2.22. What is the difference between the highest and the lowest CO2 emissions (% of total fuel combustion) of Venezuela?
Provide a succinct answer. 0.06. 